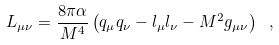Convert formula to latex. <formula><loc_0><loc_0><loc_500><loc_500>L _ { \mu \nu } = \frac { 8 \pi \alpha } { M ^ { 4 } } \left ( q _ { \mu } q _ { \nu } - l _ { \mu } l _ { \nu } - M ^ { 2 } g _ { \mu \nu } \right ) \ ,</formula> 